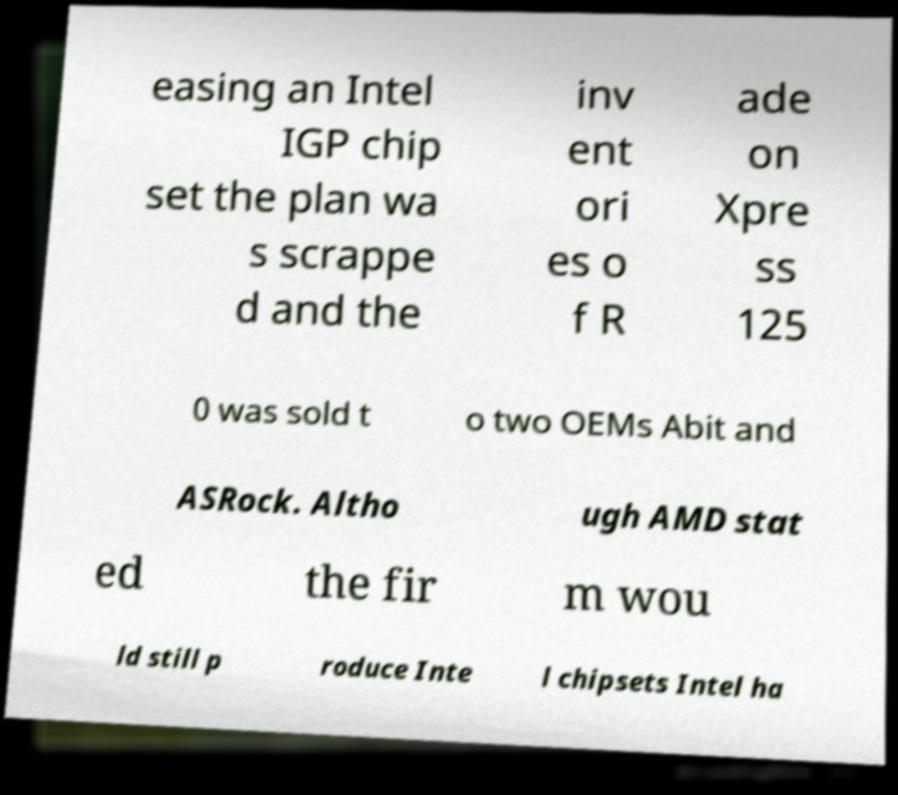For documentation purposes, I need the text within this image transcribed. Could you provide that? easing an Intel IGP chip set the plan wa s scrappe d and the inv ent ori es o f R ade on Xpre ss 125 0 was sold t o two OEMs Abit and ASRock. Altho ugh AMD stat ed the fir m wou ld still p roduce Inte l chipsets Intel ha 